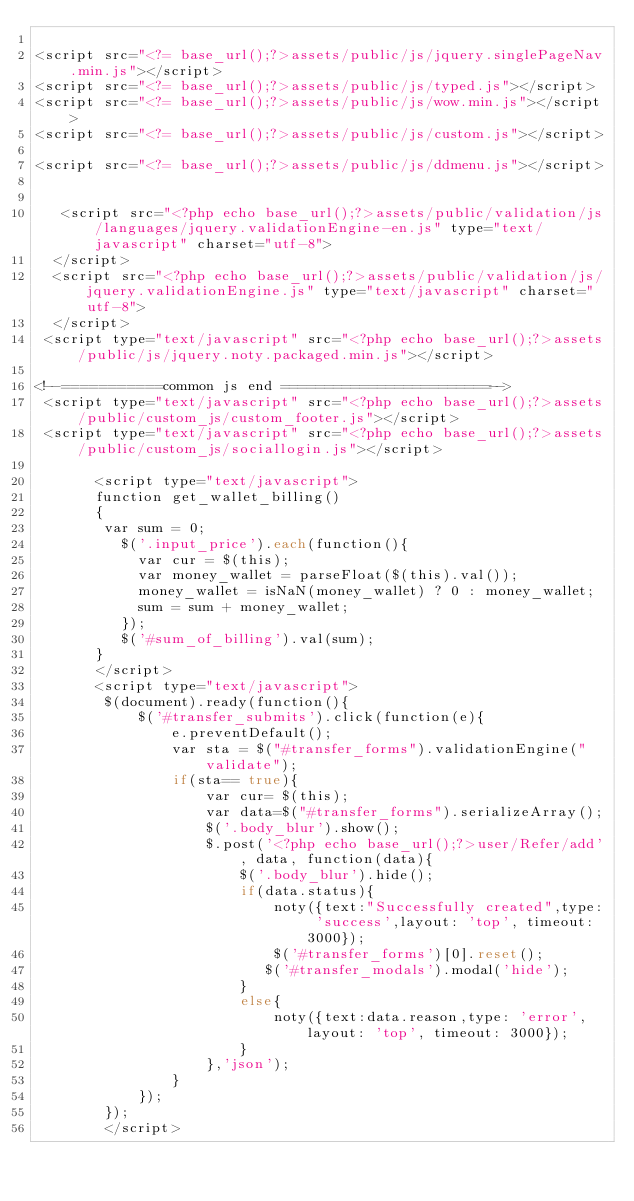Convert code to text. <code><loc_0><loc_0><loc_500><loc_500><_PHP_>
<script src="<?= base_url();?>assets/public/js/jquery.singlePageNav.min.js"></script> 
<script src="<?= base_url();?>assets/public/js/typed.js"></script> 
<script src="<?= base_url();?>assets/public/js/wow.min.js"></script> 
<script src="<?= base_url();?>assets/public/js/custom.js"></script>

<script src="<?= base_url();?>assets/public/js/ddmenu.js"></script>


   <script src="<?php echo base_url();?>assets/public/validation/js/languages/jquery.validationEngine-en.js" type="text/javascript" charset="utf-8">
  </script>
  <script src="<?php echo base_url();?>assets/public/validation/js/jquery.validationEngine.js" type="text/javascript" charset="utf-8">
  </script>
 <script type="text/javascript" src="<?php echo base_url();?>assets/public/js/jquery.noty.packaged.min.js"></script>

<!--===========common js end ========================--> 
 <script type="text/javascript" src="<?php echo base_url();?>assets/public/custom_js/custom_footer.js"></script>
 <script type="text/javascript" src="<?php echo base_url();?>assets/public/custom_js/sociallogin.js"></script>

       <script type="text/javascript">
       function get_wallet_billing()
       {
        var sum = 0;
          $('.input_price').each(function(){
            var cur = $(this);
            var money_wallet = parseFloat($(this).val());
            money_wallet = isNaN(money_wallet) ? 0 : money_wallet;
            sum = sum + money_wallet;
          });
          $('#sum_of_billing').val(sum);   
       }
       </script>
       <script type="text/javascript">
        $(document).ready(function(){
            $('#transfer_submits').click(function(e){
                e.preventDefault();
                var sta = $("#transfer_forms").validationEngine("validate");
                if(sta== true){
                    var cur= $(this);
                    var data=$("#transfer_forms").serializeArray();
                    $('.body_blur').show();
                    $.post('<?php echo base_url();?>user/Refer/add', data, function(data){
                        $('.body_blur').hide();
                        if(data.status){
                            noty({text:"Successfully created",type: 'success',layout: 'top', timeout: 3000});
                            $('#transfer_forms')[0].reset();
                           $('#transfer_modals').modal('hide');  
                        }
                        else{
                            noty({text:data.reason,type: 'error',layout: 'top', timeout: 3000});
                        }
                    },'json');
                }
            });
        });
        </script>

</code> 